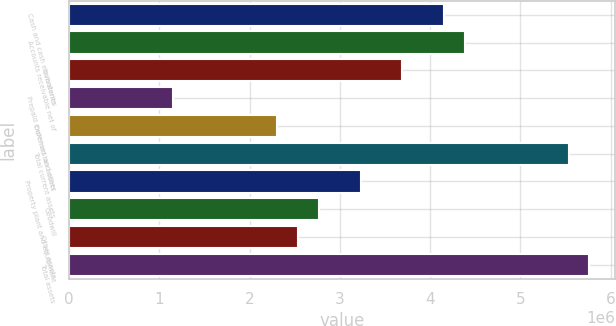<chart> <loc_0><loc_0><loc_500><loc_500><bar_chart><fcel>Cash and cash equivalents<fcel>Accounts receivable net of<fcel>Inventories<fcel>Prepaid expenses and other<fcel>Deferred tax assets<fcel>Total current assets<fcel>Property plant and equipment<fcel>Goodwill<fcel>Other assets<fcel>Total assets<nl><fcel>4.15129e+06<fcel>4.38167e+06<fcel>3.69053e+06<fcel>1.15635e+06<fcel>2.30825e+06<fcel>5.53357e+06<fcel>3.22977e+06<fcel>2.76901e+06<fcel>2.53863e+06<fcel>5.76395e+06<nl></chart> 